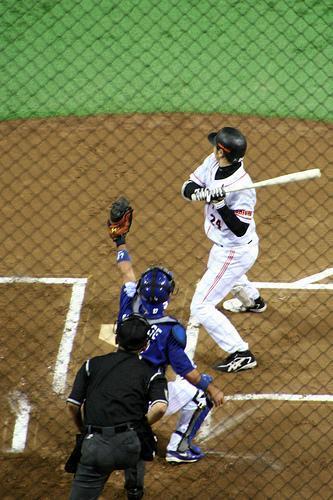How many people are in this picture?
Give a very brief answer. 3. 